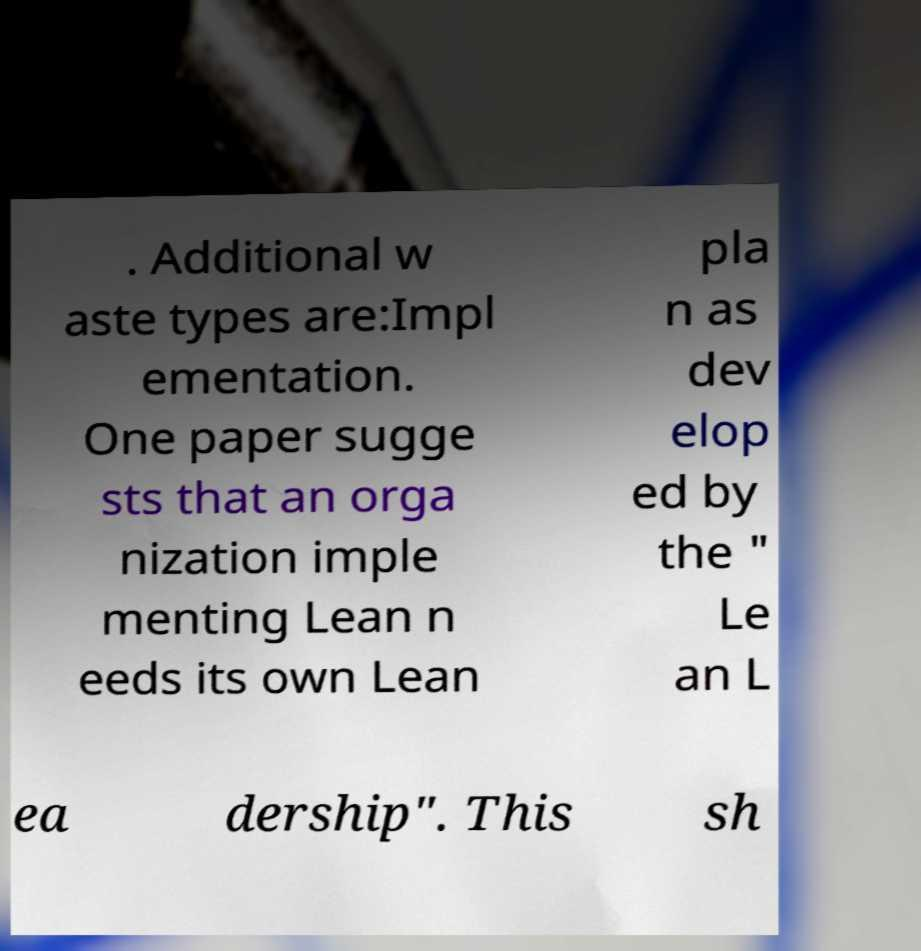For documentation purposes, I need the text within this image transcribed. Could you provide that? . Additional w aste types are:Impl ementation. One paper sugge sts that an orga nization imple menting Lean n eeds its own Lean pla n as dev elop ed by the " Le an L ea dership". This sh 